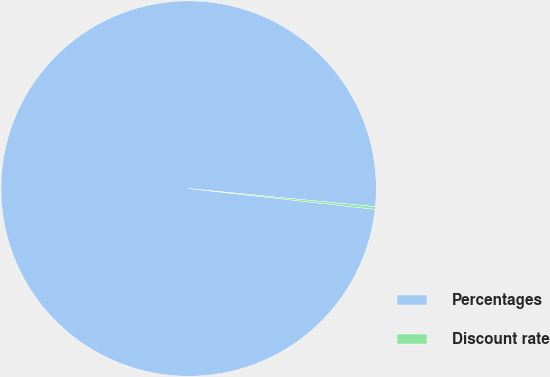<chart> <loc_0><loc_0><loc_500><loc_500><pie_chart><fcel>Percentages<fcel>Discount rate<nl><fcel>99.78%<fcel>0.22%<nl></chart> 